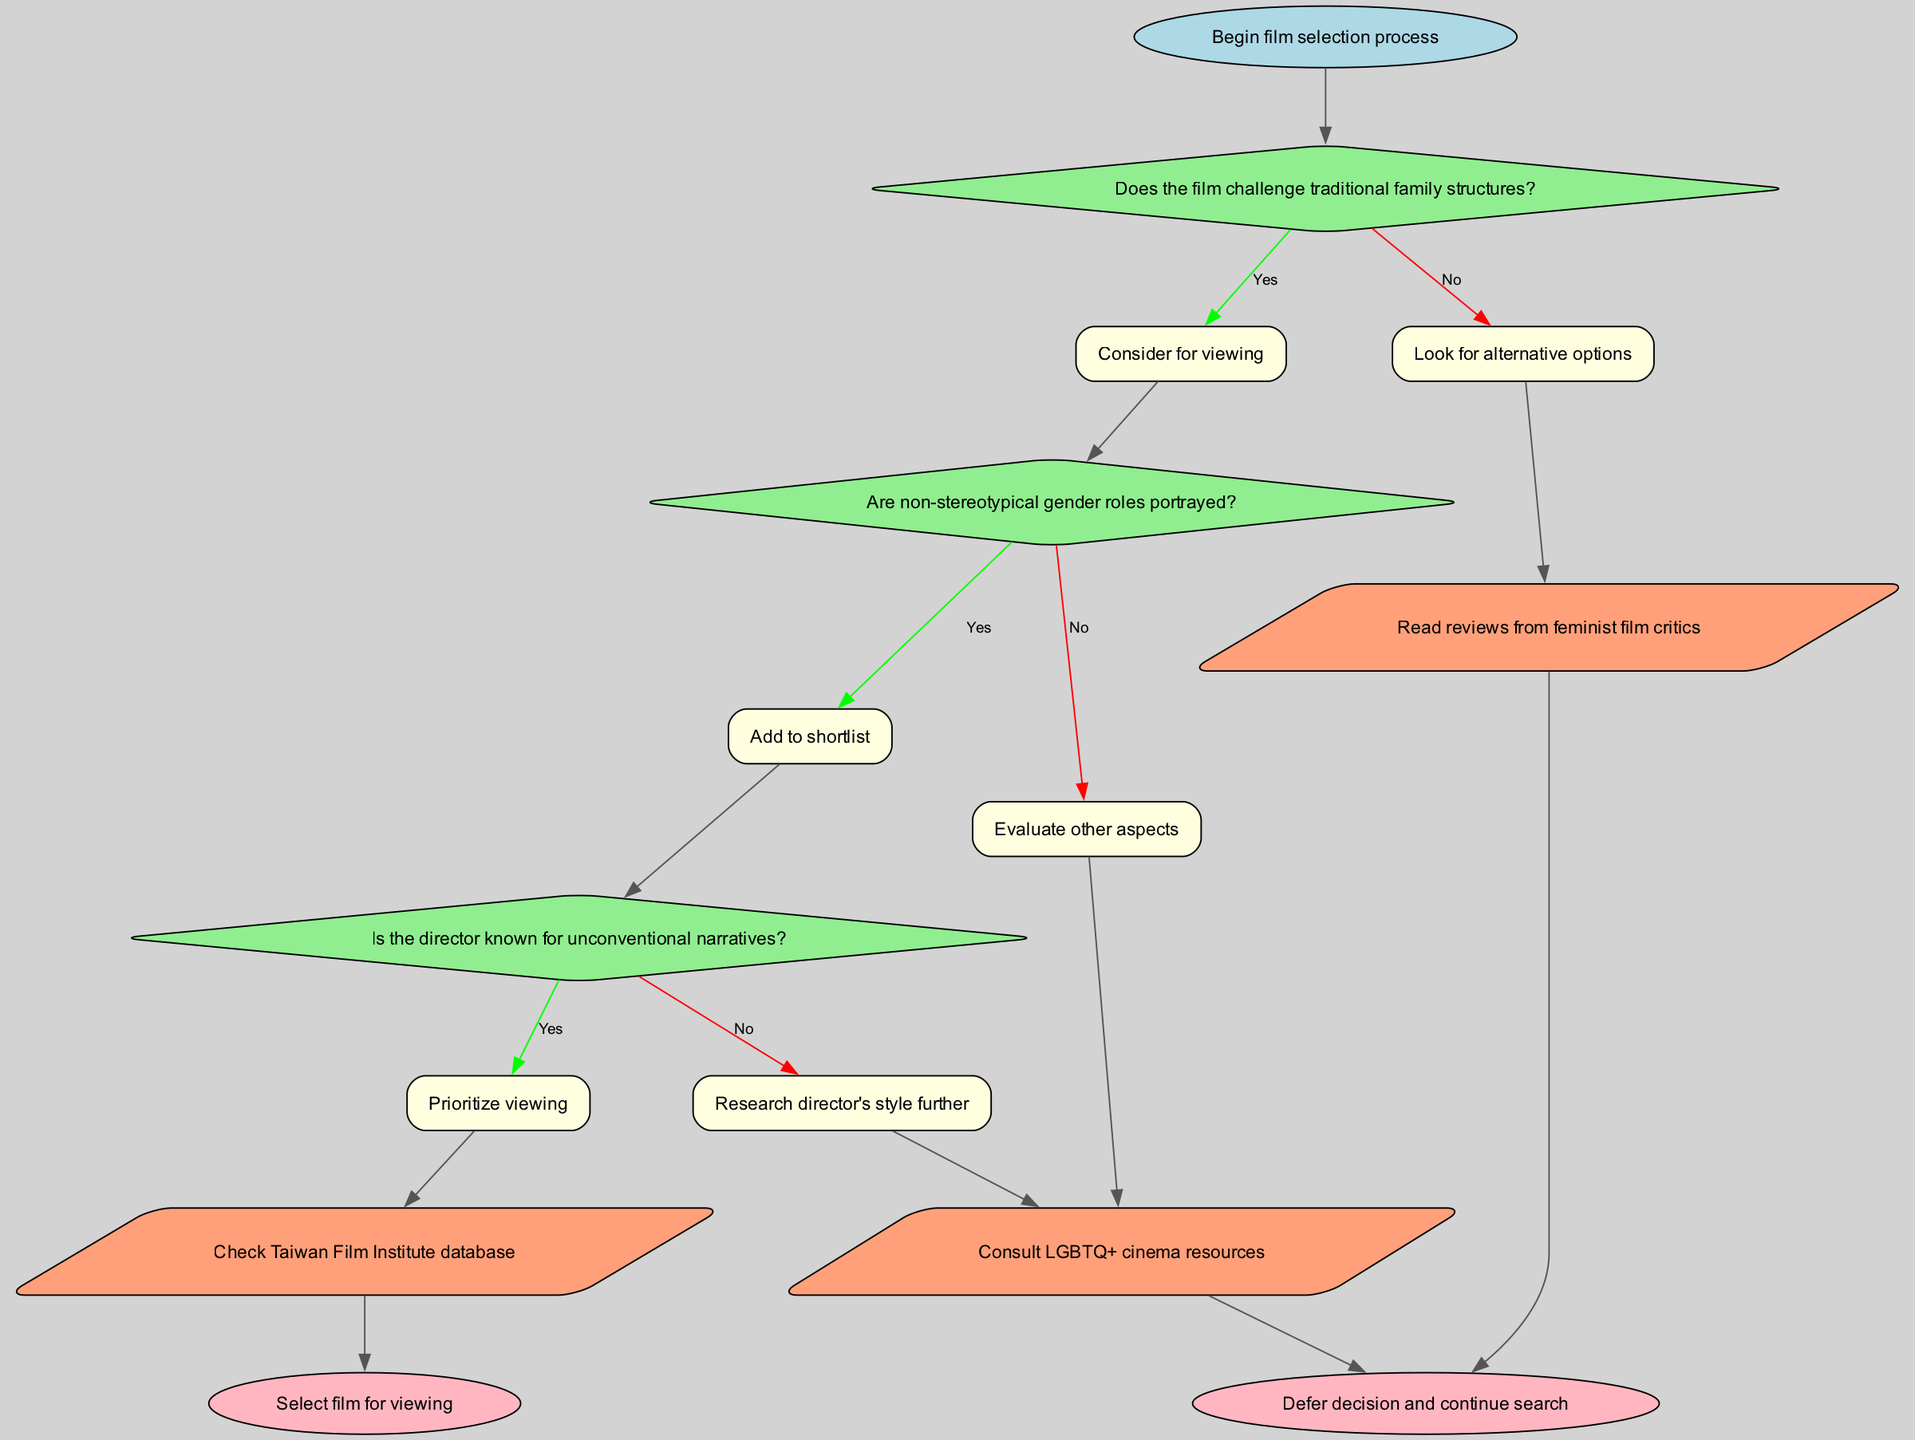What is the start point of the flowchart? The start point is labeled "Begin film selection process," indicating the initial action in the selection process.
Answer: Begin film selection process How many decision nodes are there in the diagram? The diagram contains three decision nodes, each requiring a "yes" or "no" answer.
Answer: 3 What node follows the decision about non-stereotypical gender roles? If non-stereotypical gender roles are portrayed (yes), the next node is "Add to shortlist."
Answer: Add to shortlist What happens if the answer to "Does the film challenge traditional family structures?" is no? If the answer is no, the flow moves to "Look for alternative options," indicating a shift to another search strategy.
Answer: Look for alternative options If the director is not known for unconventional narratives, what should be researched? The flowchart suggests to "Research director's style further," indicating an evaluation of the director's previous works.
Answer: Research director's style further What is the final outcome if all decisions and actions lead positively to selecting a film? The final outcome in the diagram is "Select film for viewing," representing the completion of the selection process.
Answer: Select film for viewing What action is suggested after evaluating the non-stereotypical gender roles if the answer is no? After a no answer about non-stereotypical gender roles, the suggestion is to "Evaluate other aspects," directing further analysis.
Answer: Evaluate other aspects How are the action nodes characterized in the diagram? The action nodes are shown as parallelograms and fill the purpose of guiding the viewer towards specific actions based on prior decisions.
Answer: Parallelograms 